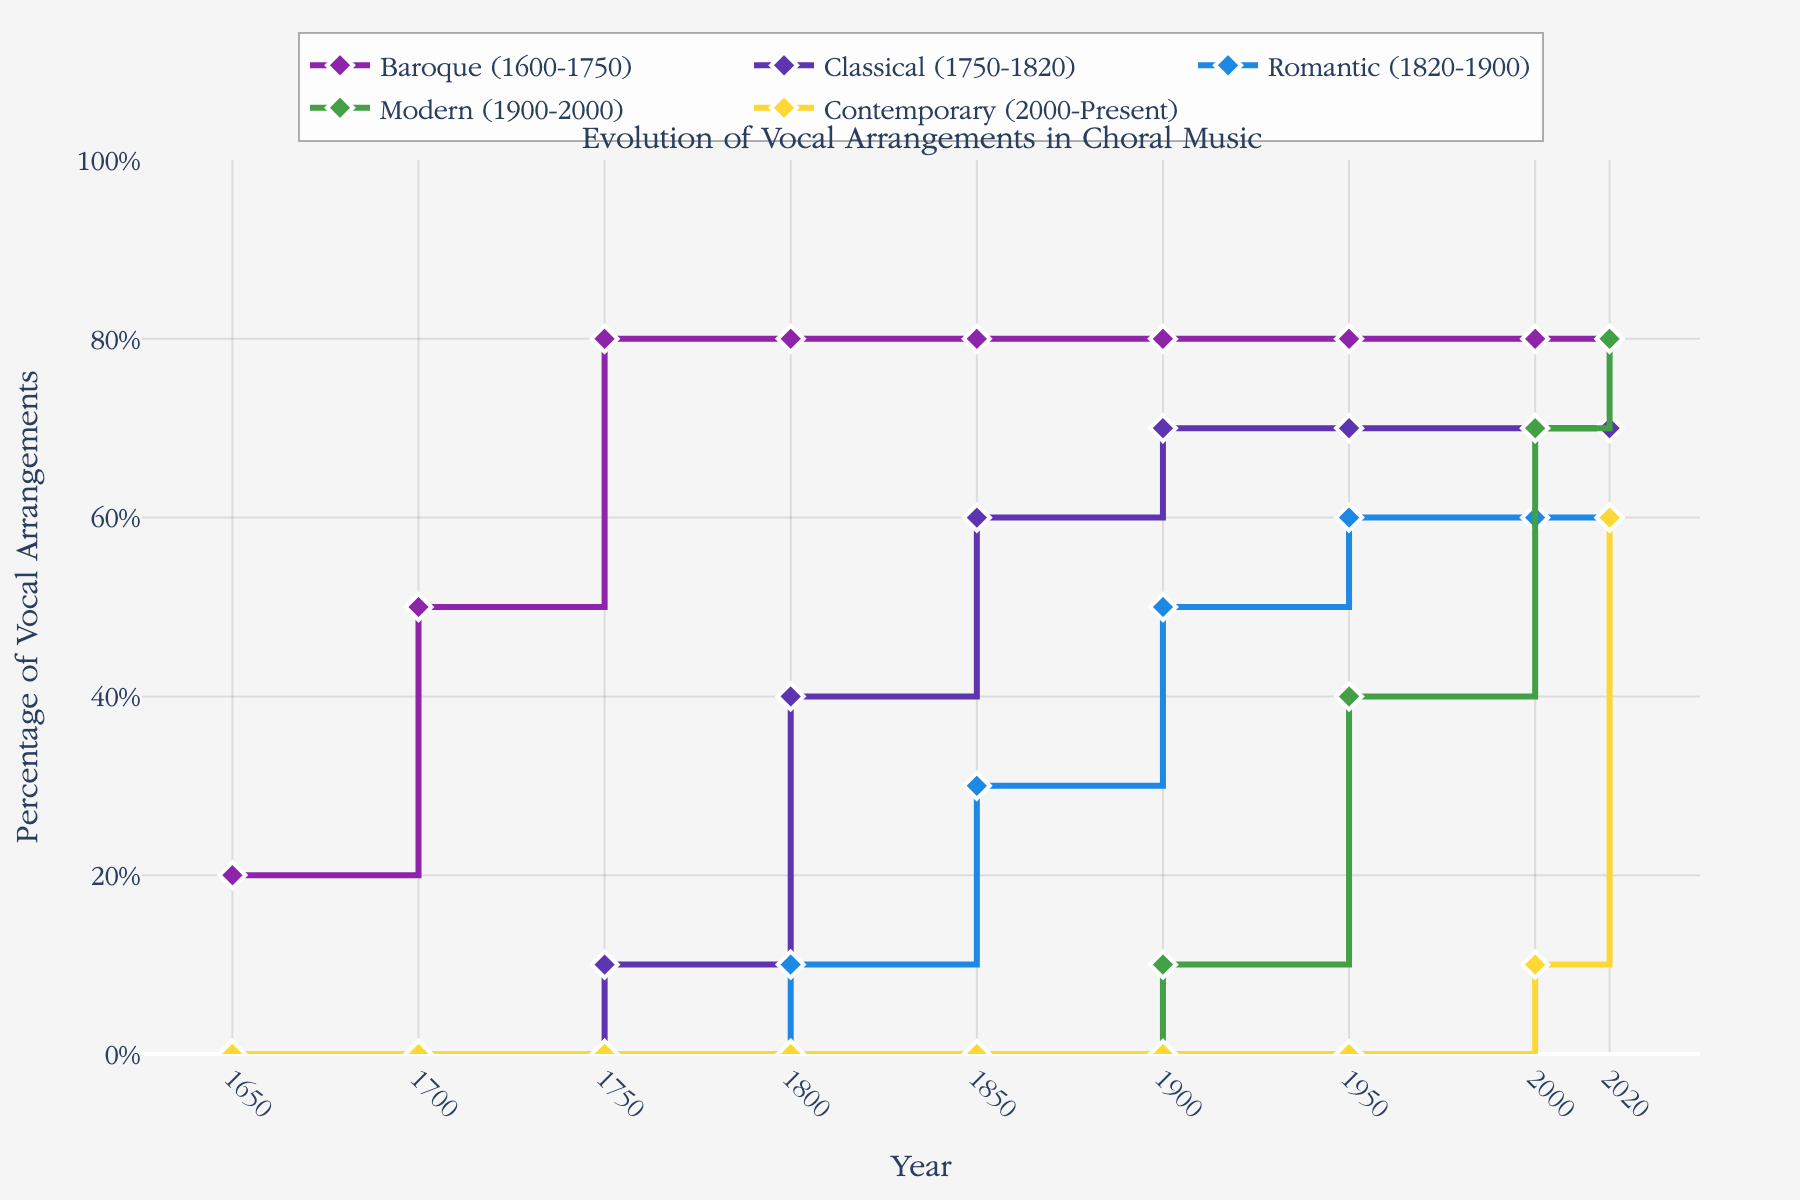What's the title of the plot? The title is found at the top of the plot. It indicates what the plot is about. The title here is "Evolution of Vocal Arrangements in Choral Music".
Answer: Evolution of Vocal Arrangements in Choral Music What are the colors used for the different periods? By observing the legends and the lines, we can see that the colors are distinct for each period: Baroque is purple, Classical is dark blue, Romantic is light blue, Modern is green, and Contemporary is yellow.
Answer: Purple, Dark Blue, Light Blue, Green, Yellow What is the highest percentage of Contemporary vocal arrangements recorded and in which year? By looking at the Contemporary curve (yellow), the highest point is at 60% in the year 2020.
Answer: 60% in 2020 During which decade did the Modern period start to have a significant percentage of vocal arrangements? Observing the green line first appearing significantly above 0%, we see it starts around the 1950s with a significant rise.
Answer: 1950s How did the percentage of Classical vocal arrangements change from 1750 to 1800? The dark blue line representing Classical shows that it increased from 10% in 1750 to 40% in 1800.
Answer: Increased from 10% to 40% Compare the percentage of Baroque and Romantic vocal arrangements in the year 1750. The purple line for Baroque is at 80%, while the light blue line for Romantic is at 0% in 1750 based on the plot data.
Answer: Baroque: 80%, Romantic: 0% What's the difference in the percentage of Modern vocal arrangements between 1950 and 2000? The green line for Modern shows 40% in 1950 and 70% in 2000. The difference is calculated as 70% - 40%.
Answer: 30% What percentage did Baroque vocal arrangements have in the year 2020, and how does it compare to its percentage in 1900? The purple line indicates 80% for Baroque in both 2020 and 1900, indicating no change.
Answer: No change, both 80% Calculate the average percentage of Romantic vocal arrangements from 1800 to 1950. The light blue line shows percentages at 1800, 1850, and 1950: 10%, 30%, and 60%. The average is (10 + 30 + 60) / 3.
Answer: 33.3% Which period had the steepest increase in vocal arrangements from 1950 to 2020? By comparing the slopes, the yellow line for Contemporary shows the steepest increase, rising from 0% in 1950 to 60% in 2020.
Answer: Contemporary 